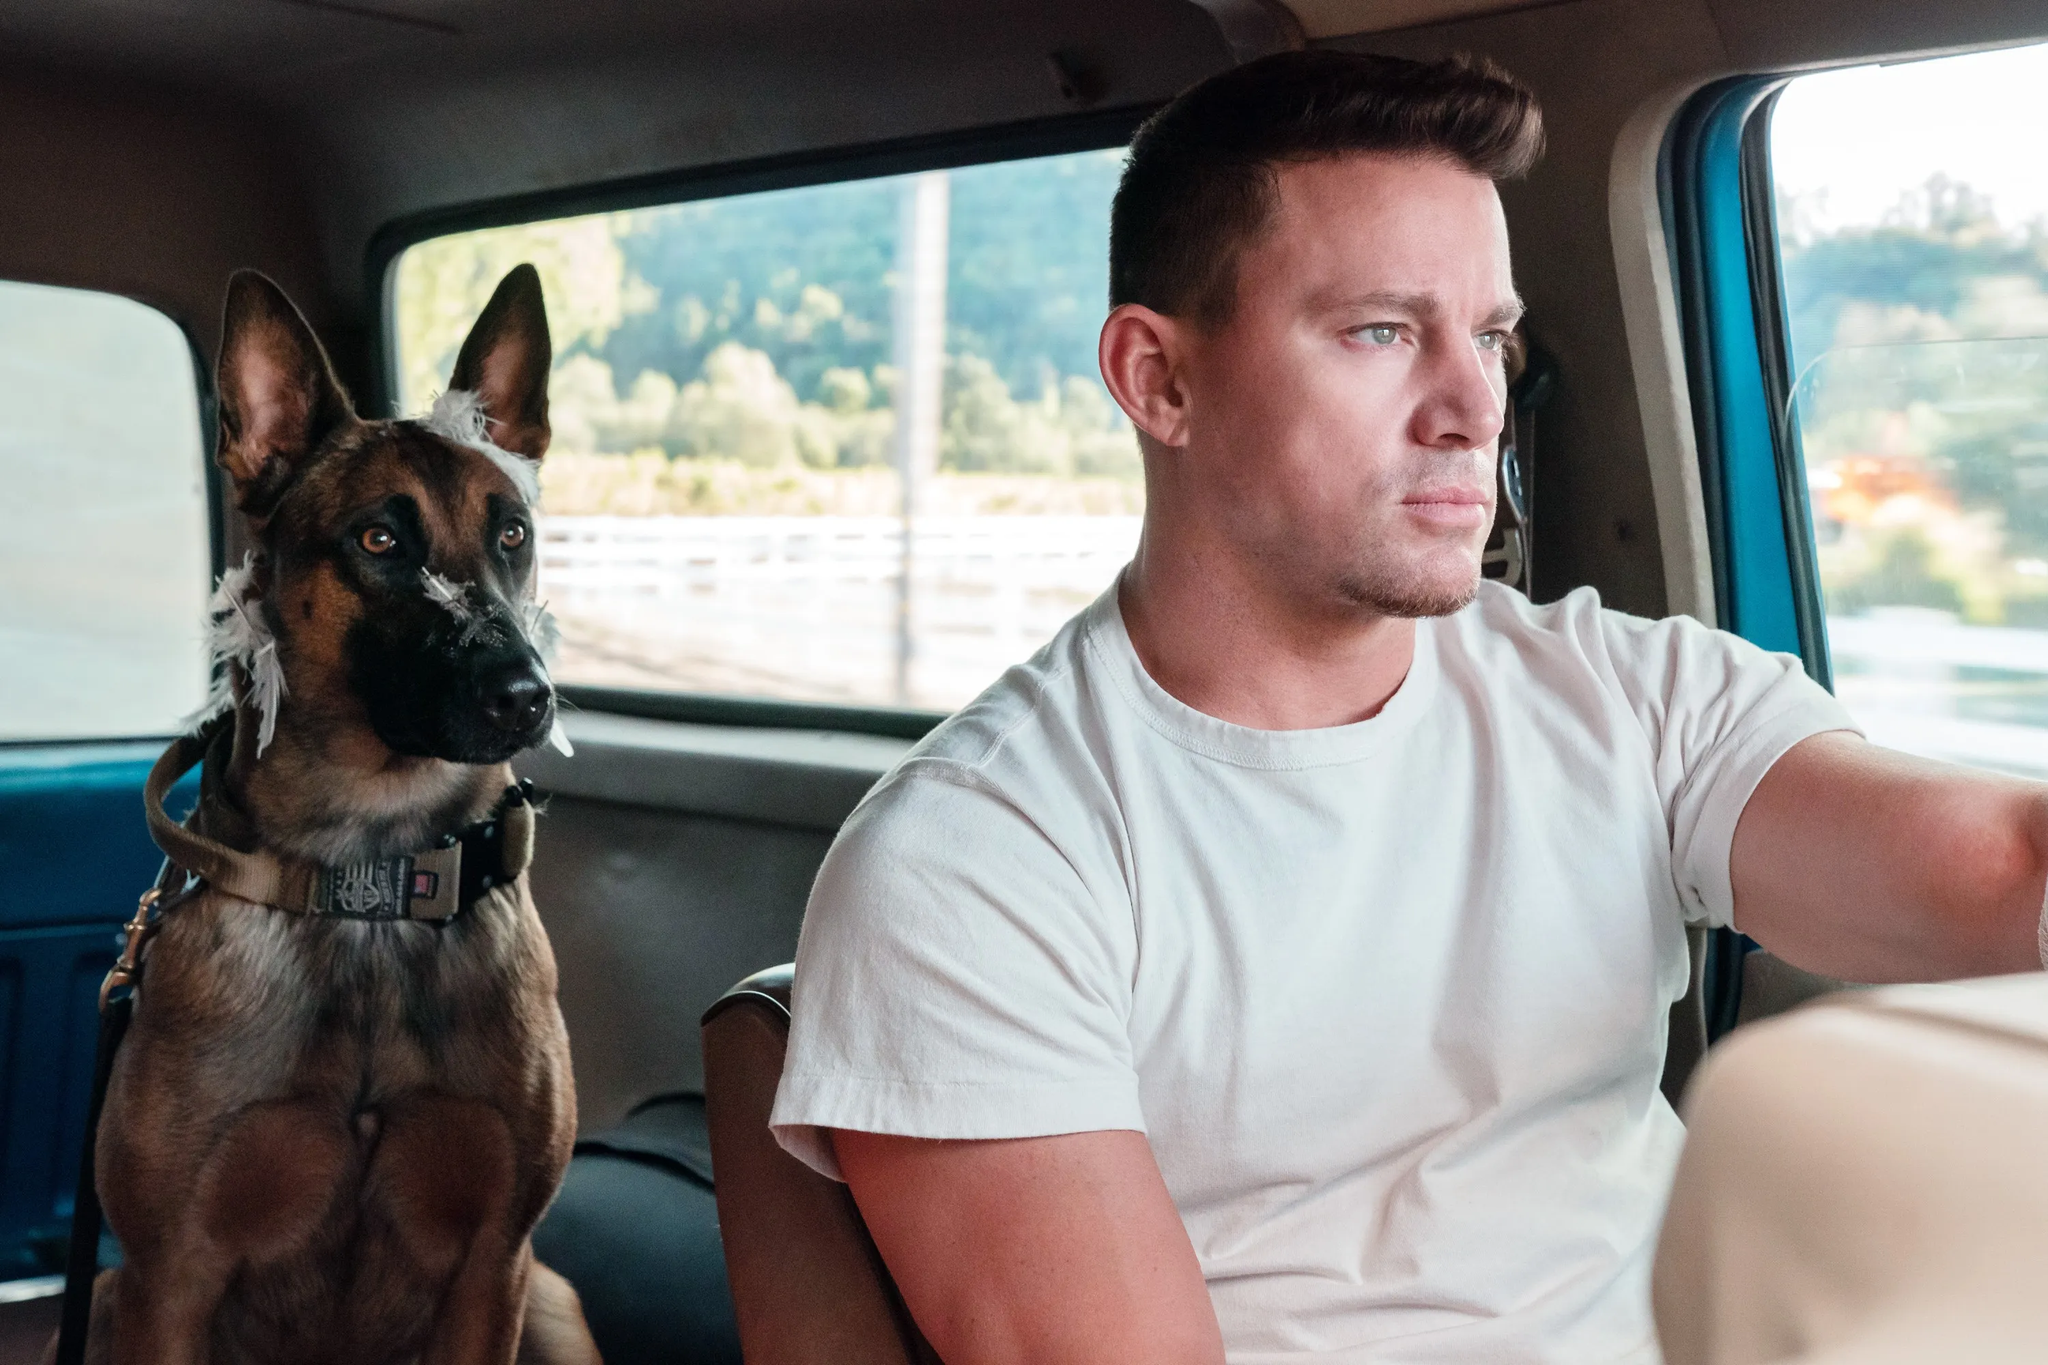Imagine the destination of their journey and describe it. Imagine their journey ends at a serene countryside retreat, surrounded by lush greenery and open spaces. As they arrive, the sound of birds chirping and a gentle breeze greets them. The man smiles as he opens the car door, and the dog excitedly leaps out, eager to explore. Together, they wander along a winding trail, encountering picturesque spots perfect for relaxation. This idyllic destination offers a perfect escape from the hustle and bustle of everyday life, providing an environment that strengthens their bond through shared experiences in nature. 